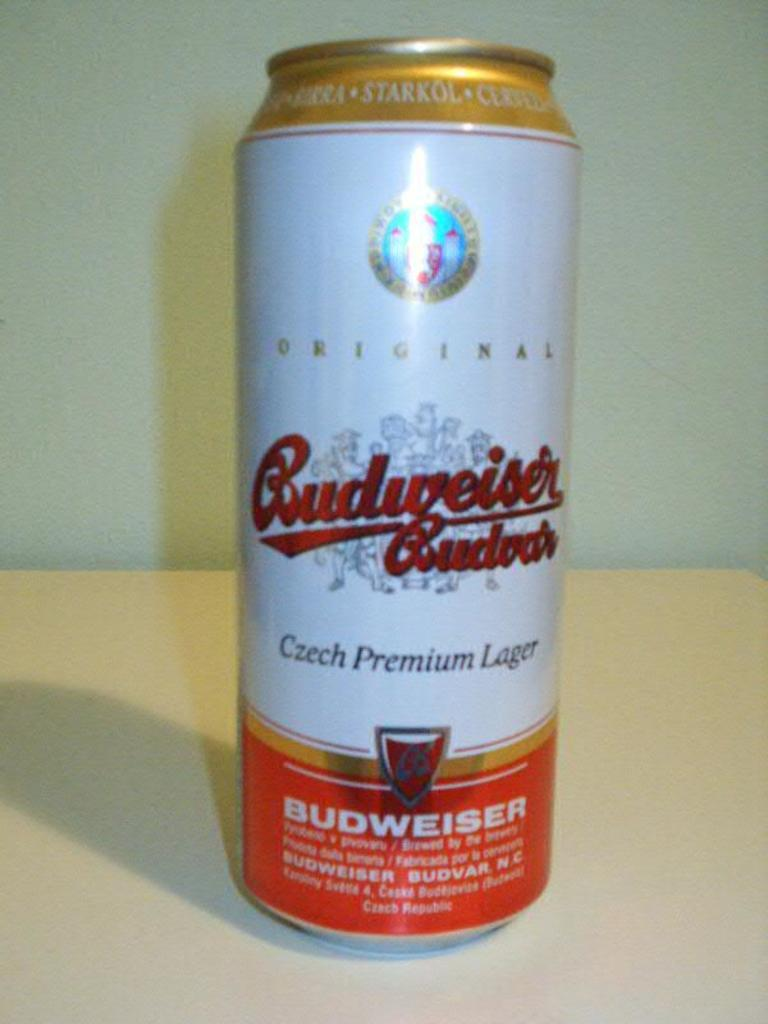Provide a one-sentence caption for the provided image. A can of Budweiser original czech premium lager. 